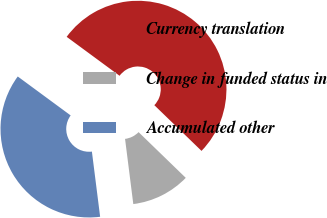Convert chart. <chart><loc_0><loc_0><loc_500><loc_500><pie_chart><fcel>Currency translation<fcel>Change in funded status in<fcel>Accumulated other<nl><fcel>52.15%<fcel>10.75%<fcel>37.1%<nl></chart> 